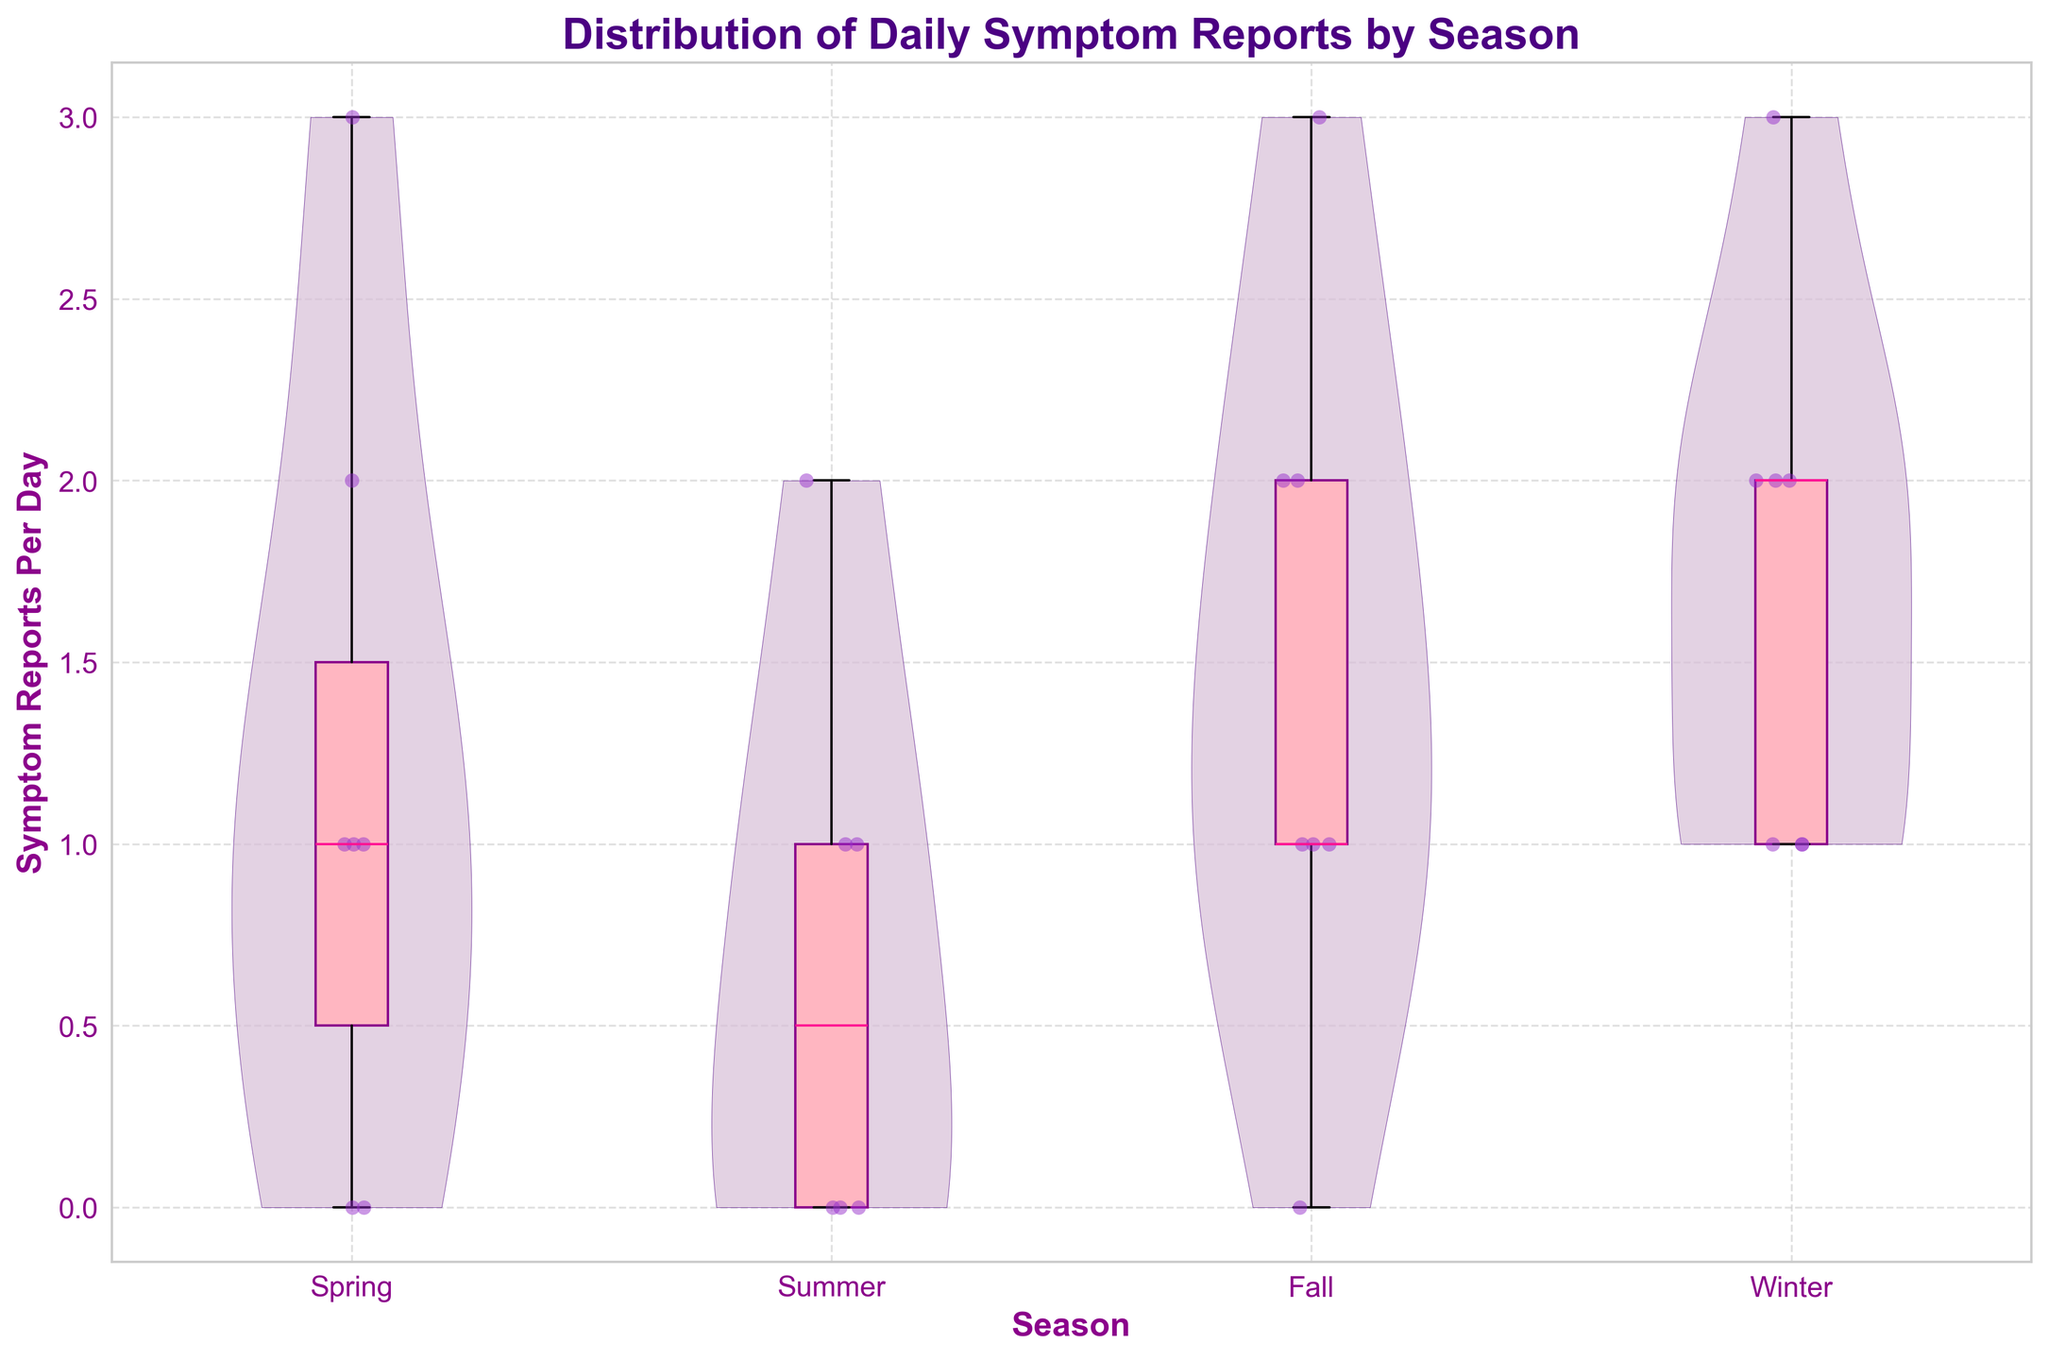What is the title of the figure? The title is usually placed at the top of the figure. In this case, the title reads "Distribution of Daily Symptom Reports by Season".
Answer: Distribution of Daily Symptom Reports by Season Which season shows the highest median of symptom reports? The median is represented by the thick horizontal line inside each box in the box plot overlay. By comparing the positions, Winter's median appears to be the highest.
Answer: Winter How many seasons are compared in this data? The x-axis labels indicate the seasons compared in the figure. Counting these labels reveals four seasons: Spring, Summer, Fall, and Winter.
Answer: 4 In which season is the interquartile range (IQR) the smallest? The IQR is the range between the lower and upper quartiles (the bottom and top edges of the box). By comparing the box sizes, Summer has the smallest IQR.
Answer: Summer What is the maximum number of symptom reports observed in Spring? The maximum is indicated by the topmost extent of the violin plot's shape or the upper whisker in the box plot. For Spring, this maximum value is 3.
Answer: 3 Which season shows the lowest variability in symptom reports? Variability is depicted by the spread or width of the violin plot. Comparing all seasons, Summer shows the narrowest violin shape, indicating the lowest variability.
Answer: Summer What is the mean number of symptom reports per day in Fall? The mean is depicted by the shape and spread within each violin plot. Since Fall’s distribution centers around 1-2, the mean is approximately between these values.
Answer: Between 1 and 2 Is there a season where no symptom reports were observed? Absence of symptom reports is represented as zeros in the data, visible as points at y=0. Summer shows zero symptom reports since there is no point or violin spread at y=0.
Answer: Yes, in Summer How do symptom reports in Winter compare to those in Summer? By comparing the width and height of the violin plots and box plots, Winter has a higher median and more data points (thicker plot) than Summer, indicating more symptom reports in Winter.
Answer: Winter has higher reports than Summer In which season is the third quartile (Q3) value the highest? The third quartile (Q3) is the top edge of each box plot. Winter has the highest top edge, making it the season with the highest Q3 value.
Answer: Winter 